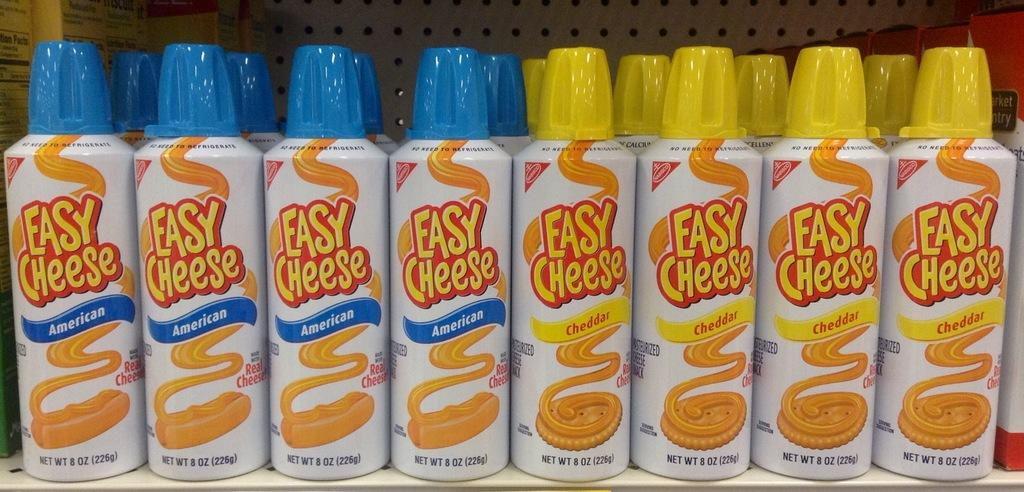Provide a one-sentence caption for the provided image. Four cans of American easy cheese to the left and four Cheddar easy cheese to the right, on a shelf with more behind each bottle. 